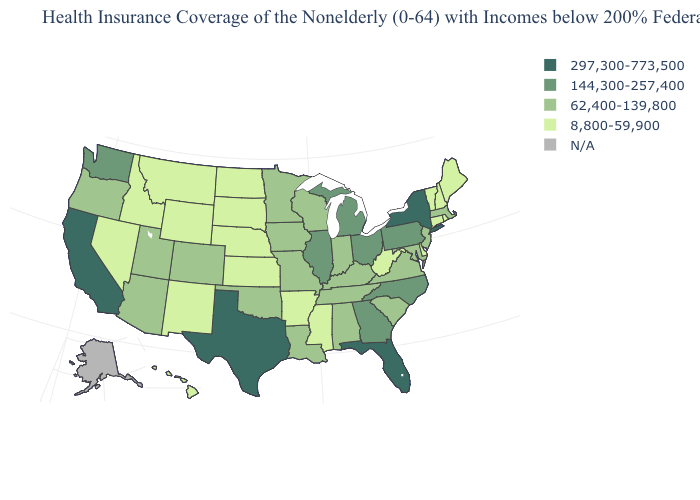Which states have the highest value in the USA?
Write a very short answer. California, Florida, New York, Texas. What is the value of Alabama?
Answer briefly. 62,400-139,800. What is the highest value in the West ?
Concise answer only. 297,300-773,500. Does New York have the highest value in the USA?
Keep it brief. Yes. What is the value of North Dakota?
Quick response, please. 8,800-59,900. Among the states that border Washington , which have the lowest value?
Concise answer only. Idaho. Name the states that have a value in the range N/A?
Short answer required. Alaska. Does Pennsylvania have the lowest value in the Northeast?
Keep it brief. No. What is the lowest value in the USA?
Be succinct. 8,800-59,900. Does the first symbol in the legend represent the smallest category?
Answer briefly. No. Does Oregon have the highest value in the West?
Give a very brief answer. No. Is the legend a continuous bar?
Give a very brief answer. No. Name the states that have a value in the range N/A?
Keep it brief. Alaska. What is the value of Delaware?
Give a very brief answer. 8,800-59,900. 